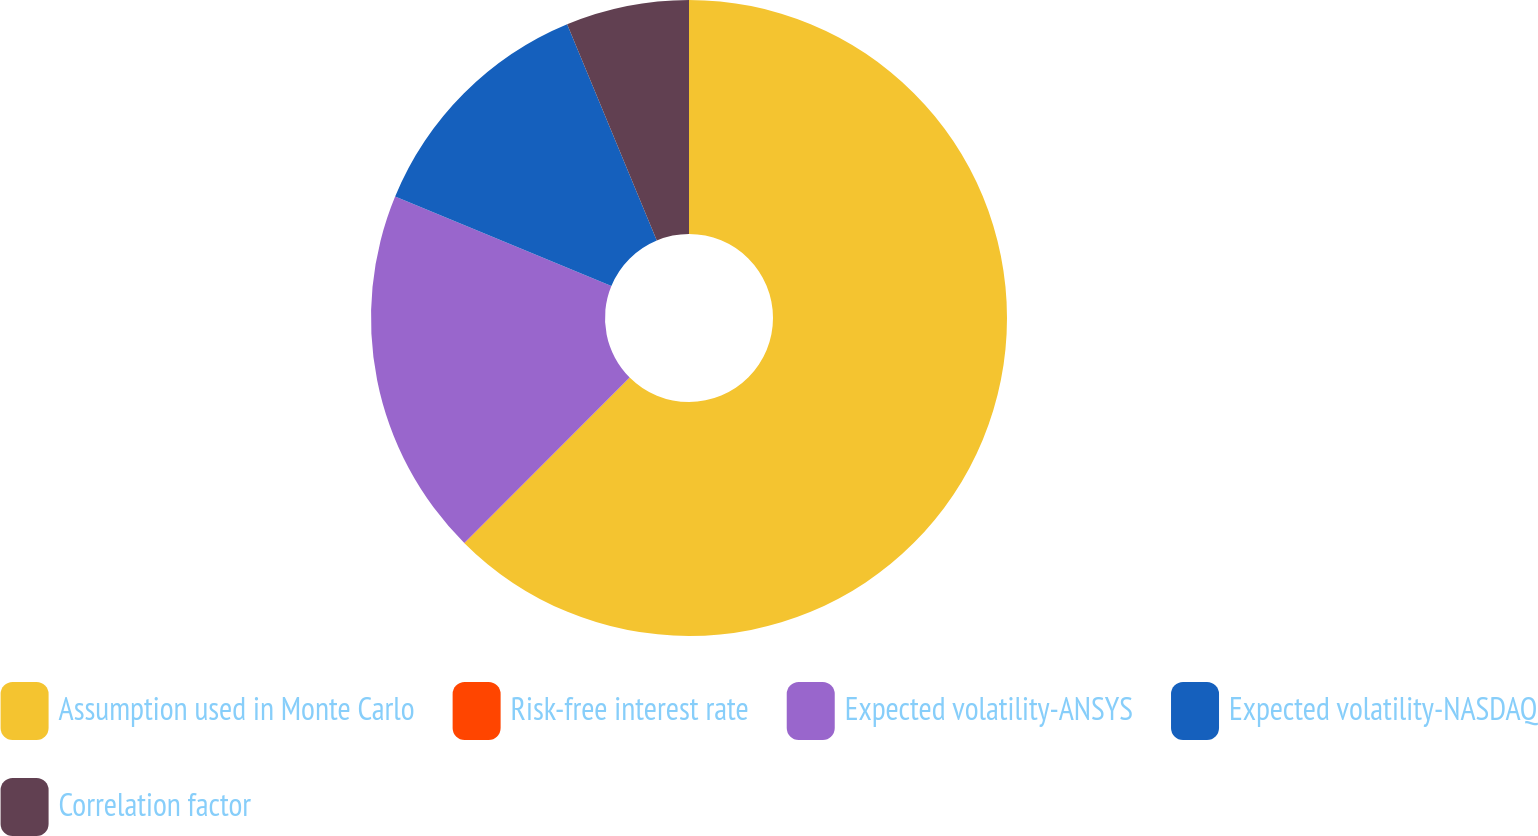Convert chart to OTSL. <chart><loc_0><loc_0><loc_500><loc_500><pie_chart><fcel>Assumption used in Monte Carlo<fcel>Risk-free interest rate<fcel>Expected volatility-ANSYS<fcel>Expected volatility-NASDAQ<fcel>Correlation factor<nl><fcel>62.48%<fcel>0.01%<fcel>18.75%<fcel>12.5%<fcel>6.26%<nl></chart> 